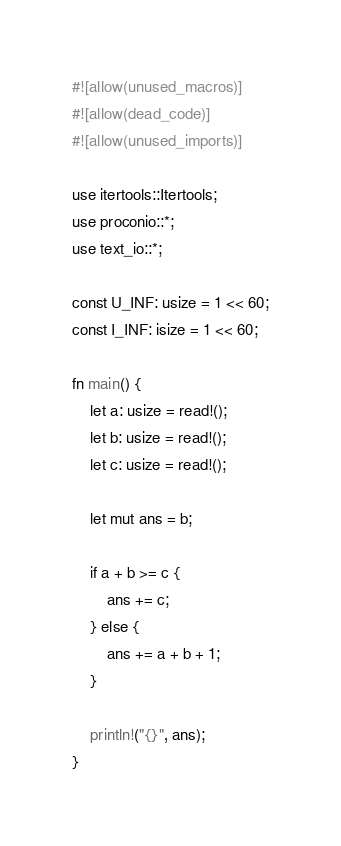Convert code to text. <code><loc_0><loc_0><loc_500><loc_500><_Rust_>#![allow(unused_macros)]
#![allow(dead_code)]
#![allow(unused_imports)]

use itertools::Itertools;
use proconio::*;
use text_io::*;

const U_INF: usize = 1 << 60;
const I_INF: isize = 1 << 60;

fn main() {
    let a: usize = read!();
    let b: usize = read!();
    let c: usize = read!();

    let mut ans = b;

    if a + b >= c {
        ans += c;
    } else {
        ans += a + b + 1;
    }

    println!("{}", ans);
}
</code> 